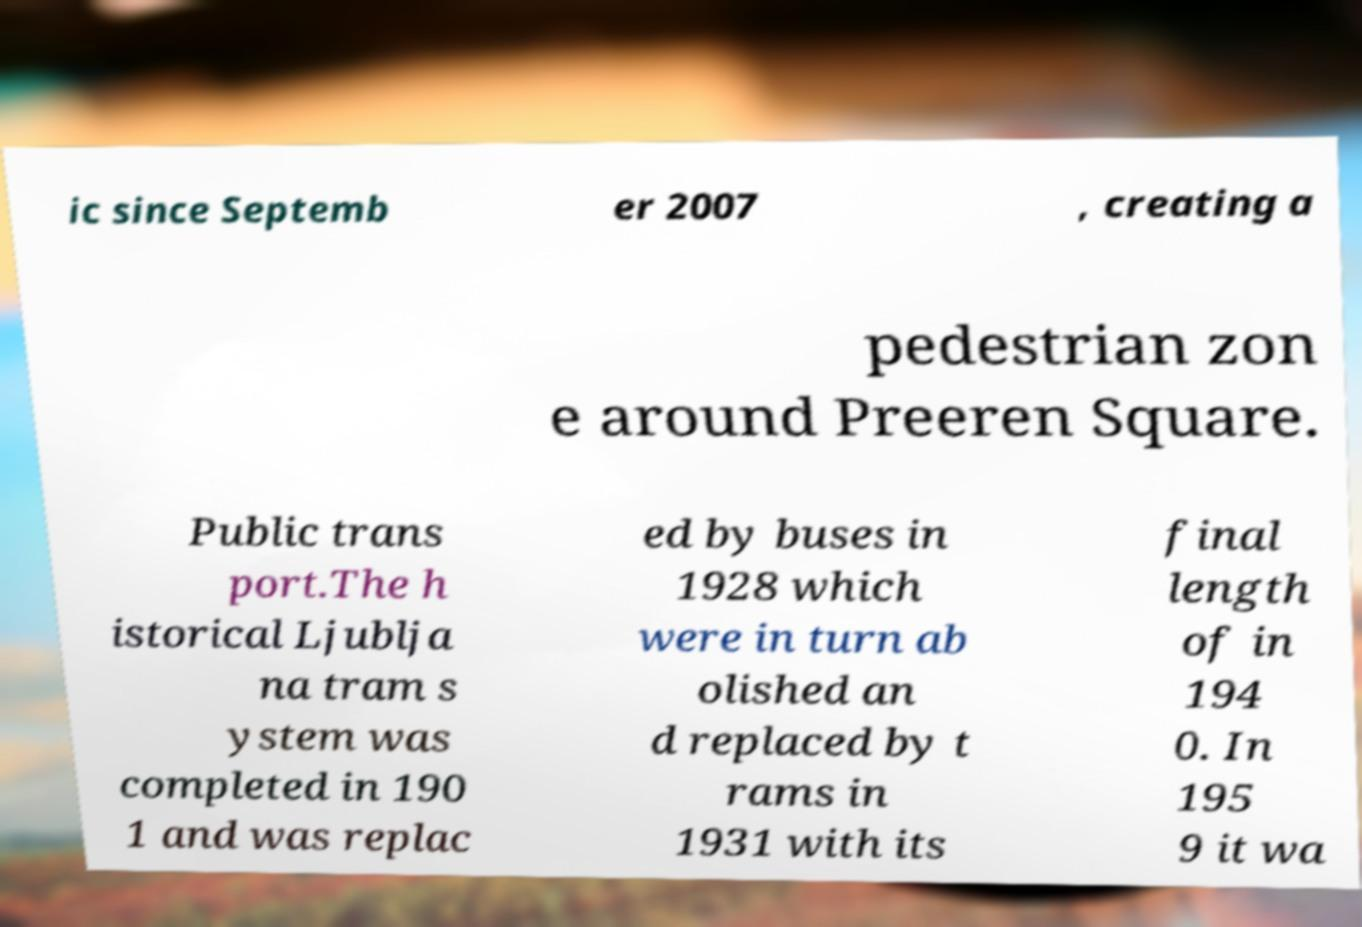There's text embedded in this image that I need extracted. Can you transcribe it verbatim? ic since Septemb er 2007 , creating a pedestrian zon e around Preeren Square. Public trans port.The h istorical Ljublja na tram s ystem was completed in 190 1 and was replac ed by buses in 1928 which were in turn ab olished an d replaced by t rams in 1931 with its final length of in 194 0. In 195 9 it wa 